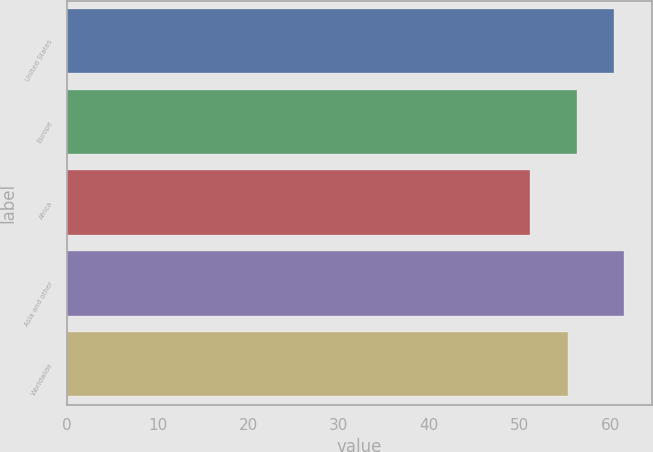Convert chart to OTSL. <chart><loc_0><loc_0><loc_500><loc_500><bar_chart><fcel>United States<fcel>Europe<fcel>Africa<fcel>Asia and other<fcel>Worldwide<nl><fcel>60.45<fcel>56.34<fcel>51.18<fcel>61.52<fcel>55.31<nl></chart> 